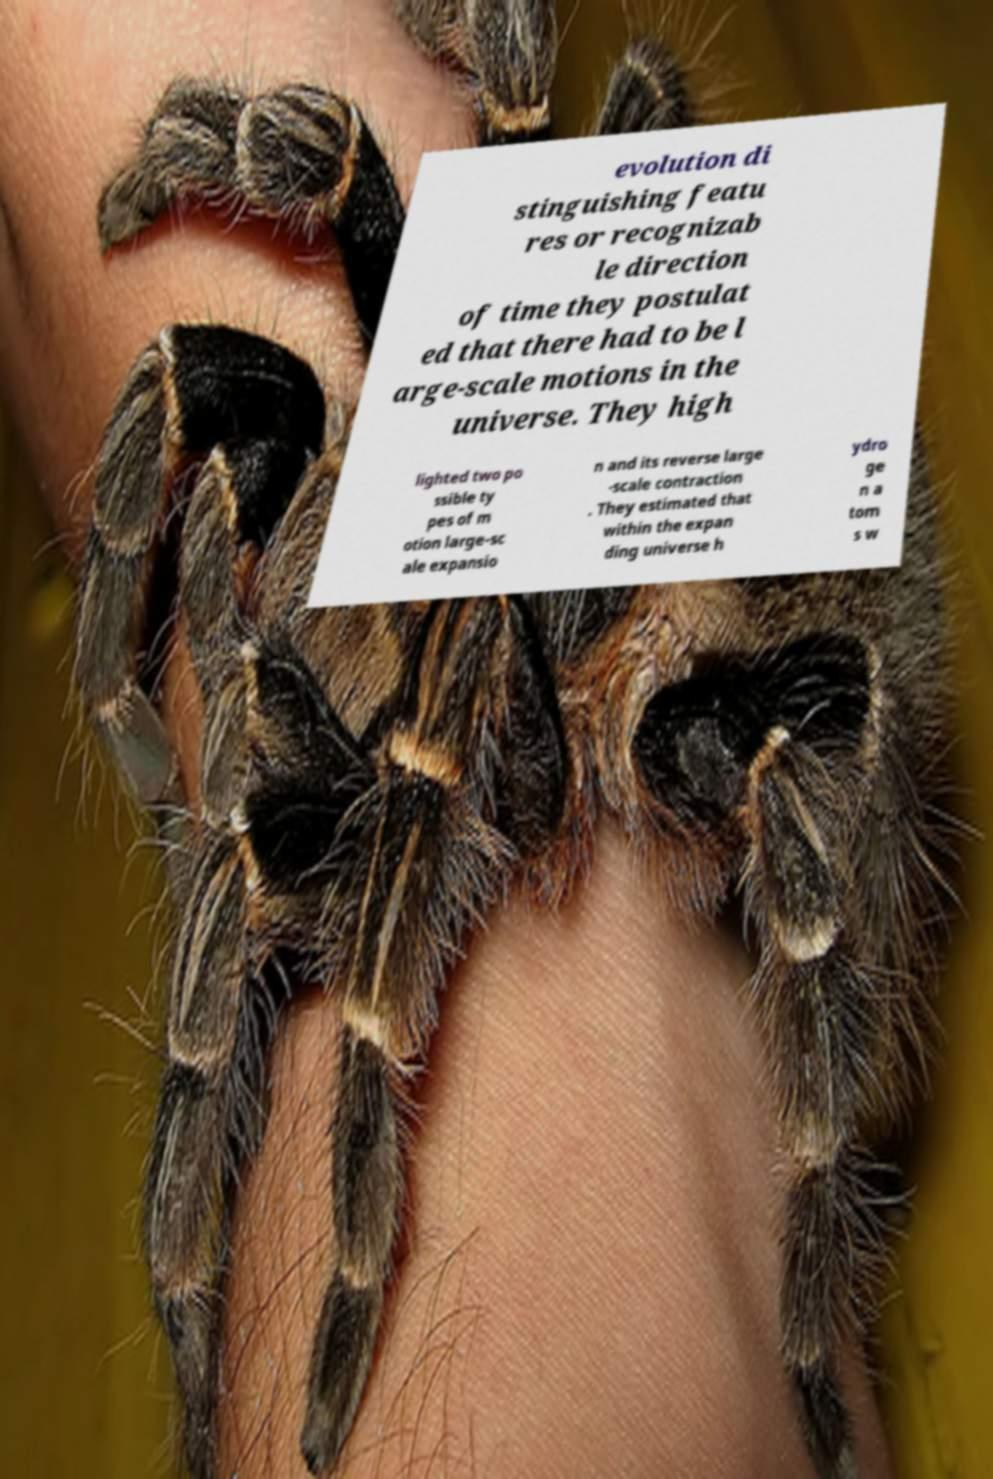Could you extract and type out the text from this image? evolution di stinguishing featu res or recognizab le direction of time they postulat ed that there had to be l arge-scale motions in the universe. They high lighted two po ssible ty pes of m otion large-sc ale expansio n and its reverse large -scale contraction . They estimated that within the expan ding universe h ydro ge n a tom s w 